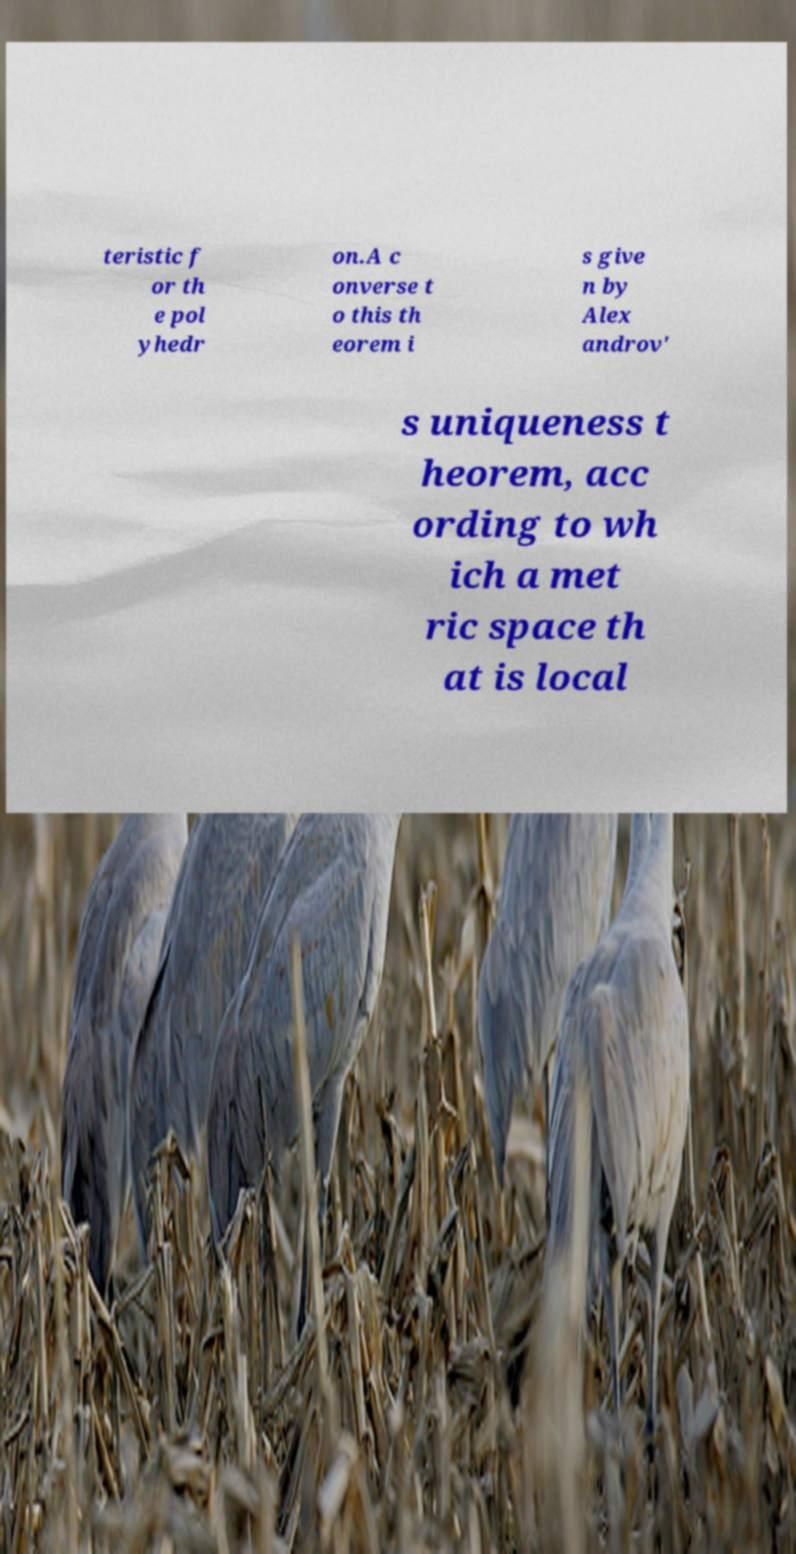For documentation purposes, I need the text within this image transcribed. Could you provide that? teristic f or th e pol yhedr on.A c onverse t o this th eorem i s give n by Alex androv' s uniqueness t heorem, acc ording to wh ich a met ric space th at is local 